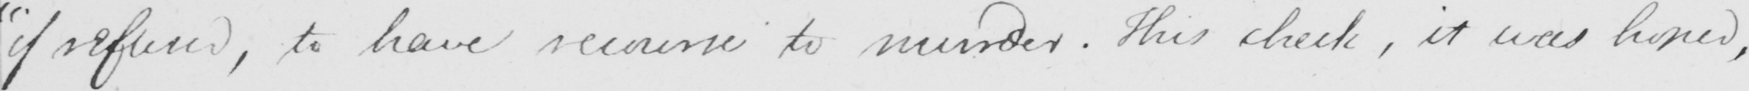What does this handwritten line say? " if refused , to have recourse to murder . This check , it was hoped , 